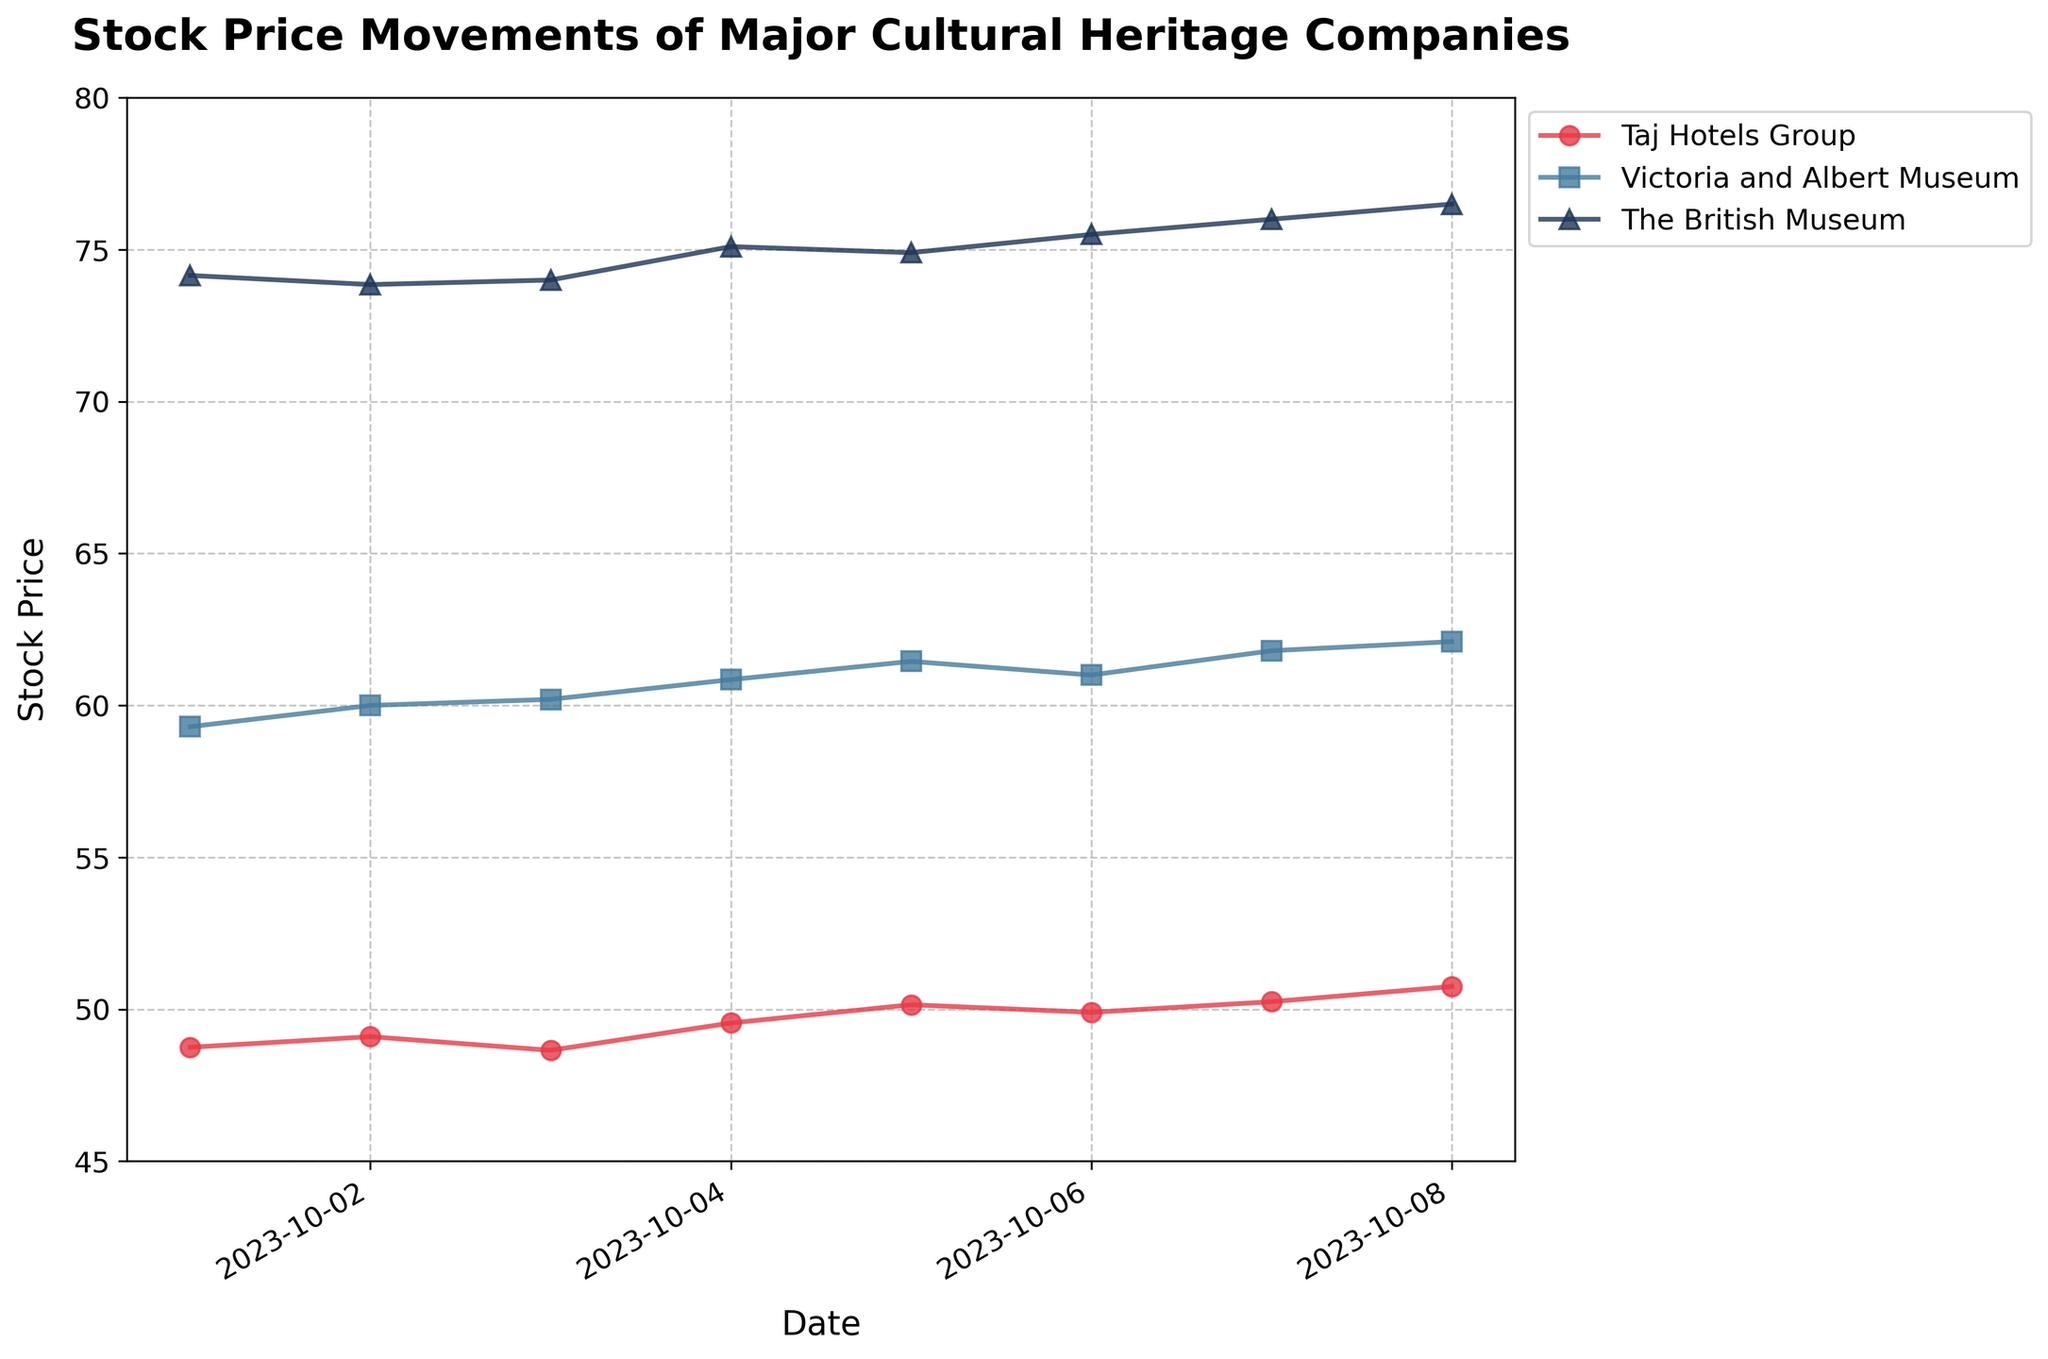What's the title of the plot? The title of the plot is displayed at the top within the plot area. It describes what the plot is depicting.
Answer: Stock Price Movements of Major Cultural Heritage Companies Which company had the highest stock price on October 1, 2023? By examining the stock prices for October 1, 2023, we can compare the values. The British Museum had the highest stock price of 74.15.
Answer: The British Museum How did the stock price of Taj Hotels Group change from October 1 to October 8, 2023? By looking at the stock price values of Taj Hotels Group over the dates provided, we can observe the changes: from 48.75 on October 1 to 50.75 on October 8. This indicates an overall increase of 2.00 units in stock price.
Answer: Increased by 2.00 units Which day did the Victoria and Albert Museum have its highest stock price, and what was that price? We need to check the stock prices of the Victoria and Albert Museum across different dates, and identify the maximum value, which is 62.10 on October 8, 2023.
Answer: October 8, 62.10 Between October 4 and October 7, which company had the biggest increase in stock price, and what was the increase? By calculating the change in stock price for each company between October 4 and October 7, we get:
- Taj Hotels Group: 50.25 - 49.55 = 0.70
- Victoria and Albert Museum: 61.80 - 60.85 = 0.95
- The British Museum: 76.00 - 75.10 = 0.90
The Victoria and Albert Museum had the highest increase of 0.95 units.
Answer: Victoria and Albert Museum, 0.95 units What is the trend of The British Museum's stock price over the provided dates? By examining the stock prices of The British Museum from October 1 to October 8, we can observe that the stock price mostly increased with some minor fluctuations, indicating an overall upward trend.
Answer: Upward trend Compare the stock price of Taj Hotels Group and The British Museum on October 7, 2023. Which one was higher, and by how much? The stock prices on October 7, 2023, are 50.25 for Taj Hotels Group and 76.00 for The British Museum. The British Museum's stock price is higher by 76.00 - 50.25 = 25.75 units.
Answer: The British Museum, 25.75 units What was the average stock price of Victoria and Albert Museum from October 1 to October 8, 2023? To find the average, sum up Victoria and Albert Museum's stock prices over the dates and divide by the number of days.
(59.30 + 60.00 + 60.20 + 60.85 + 61.45 + 61.00 + 61.80 + 62.10) / 8 = 60.84.
Answer: 60.84 Did any company's stock price decline between any days within October 1 to October 8, 2023? Checking all three companies across the dates:
- Taj Hotels Group declined on October 3 (49.10 to 48.65)
- Victoria and Albert Museum remained steady or increased.
- The British Museum declined on October 2 (74.15 to 73.85).
Yes, both Taj Hotels Group and The British Museum had declines on one of the days.
Answer: Yes 